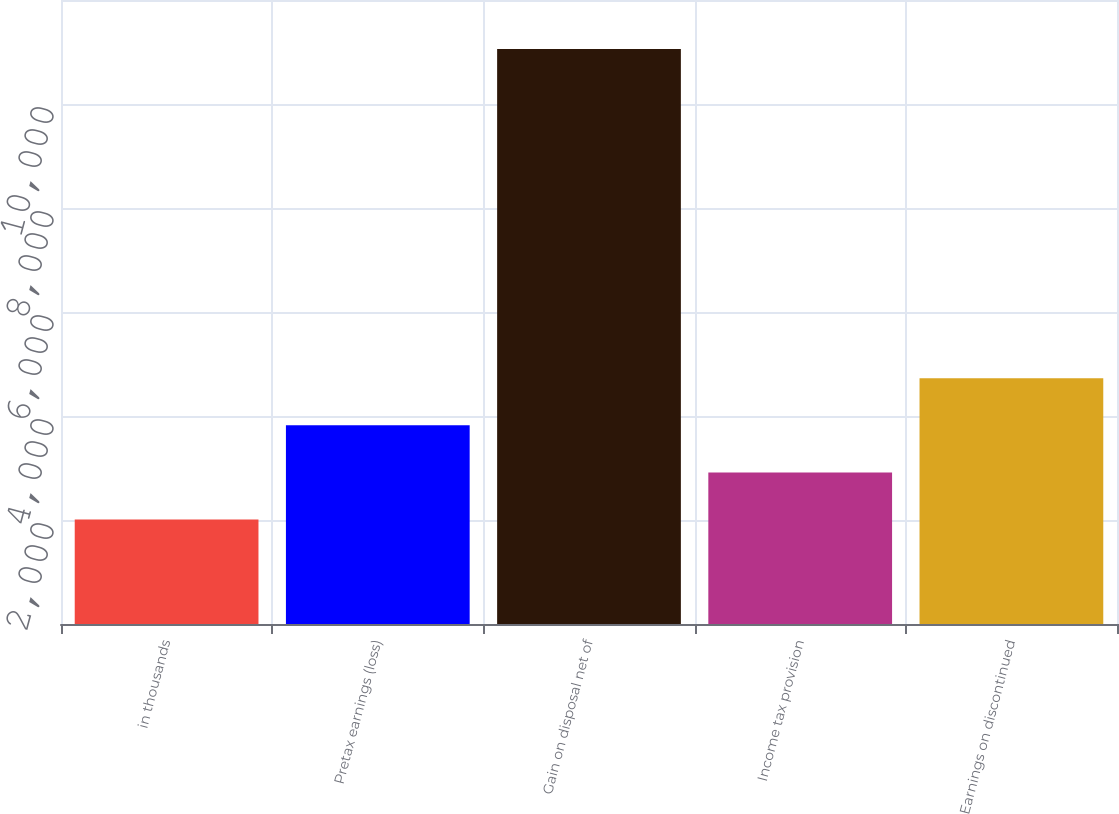<chart> <loc_0><loc_0><loc_500><loc_500><bar_chart><fcel>in thousands<fcel>Pretax earnings (loss)<fcel>Gain on disposal net of<fcel>Income tax provision<fcel>Earnings on discontinued<nl><fcel>2011<fcel>3820<fcel>11056<fcel>2915.5<fcel>4724.5<nl></chart> 